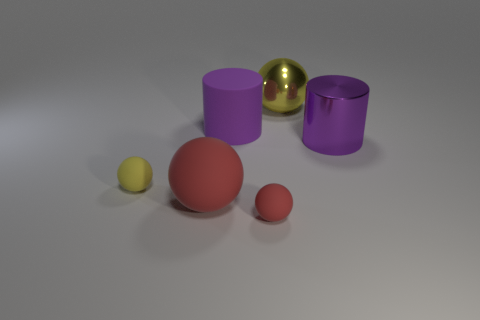How many other things are there of the same shape as the purple matte thing?
Provide a succinct answer. 1. The other ball that is the same size as the shiny sphere is what color?
Your answer should be very brief. Red. What is the color of the big metallic object that is right of the metal sphere?
Give a very brief answer. Purple. There is a large sphere behind the large red matte ball; are there any objects that are to the left of it?
Ensure brevity in your answer.  Yes. Do the large red thing and the yellow object that is to the left of the big yellow ball have the same shape?
Offer a very short reply. Yes. There is a object that is behind the purple shiny thing and on the left side of the big metallic sphere; what size is it?
Your answer should be very brief. Large. Are there any yellow things made of the same material as the large yellow sphere?
Your response must be concise. No. What size is the other cylinder that is the same color as the metal cylinder?
Give a very brief answer. Large. There is a large ball that is in front of the yellow ball in front of the big matte cylinder; what is it made of?
Your answer should be very brief. Rubber. What number of big objects have the same color as the large matte cylinder?
Your response must be concise. 1. 